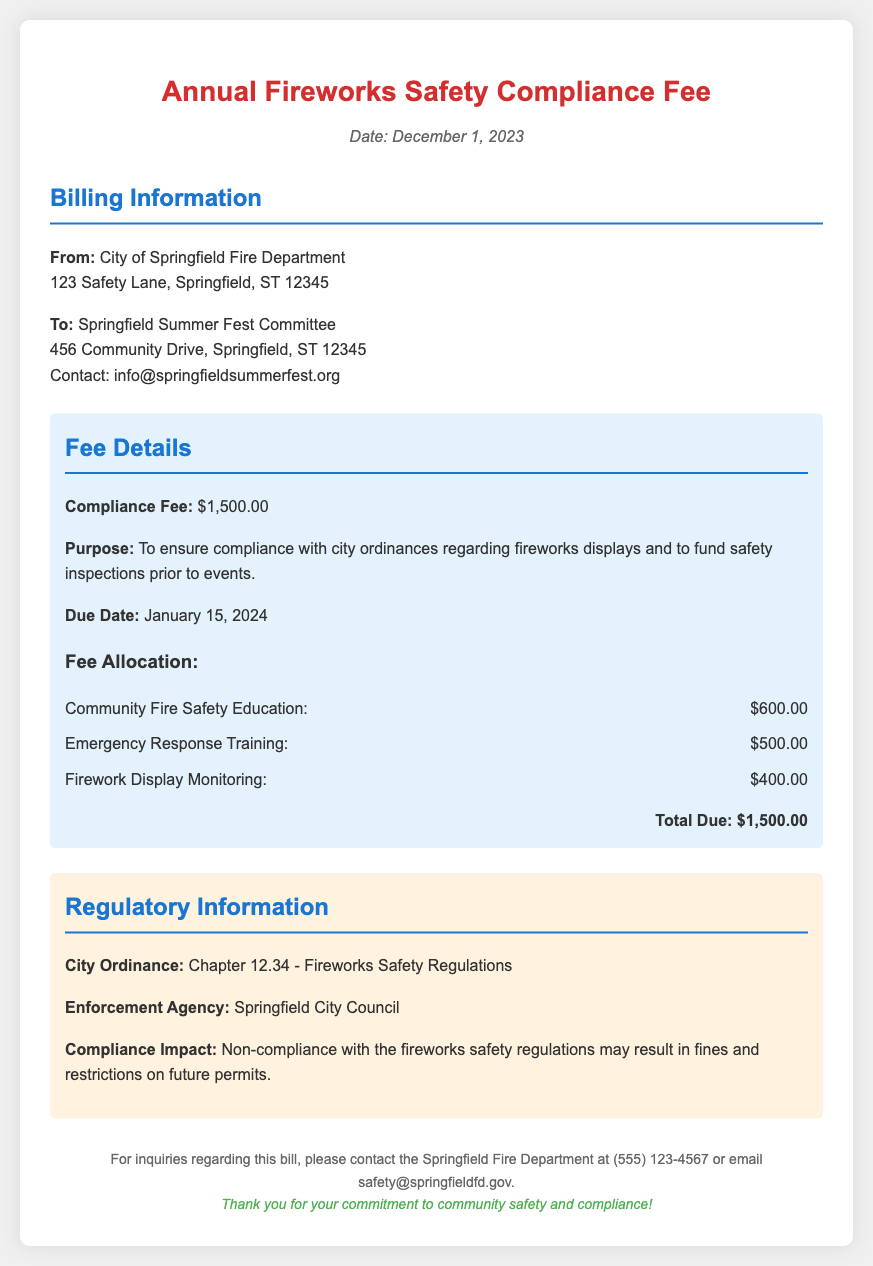What is the compliance fee amount? The compliance fee amount is specified in the bill under Fee Details.
Answer: $1,500.00 When is the due date for payment? The due date is mentioned clearly in the Fee Details section of the bill.
Answer: January 15, 2024 What are the three areas funded by the fee allocation? The bill outlines specific areas allocated from the compliance fee.
Answer: Community Fire Safety Education, Emergency Response Training, Firework Display Monitoring What is the total amount due? The total amount due is summarized as part of the fee details.
Answer: $1,500.00 Which agency enforces the fireworks safety regulations? The enforcing agency is referred to in the Regulatory Information section of the document.
Answer: Springfield City Council What might happen if an organizer does not comply with the regulations? Potential consequences of non-compliance are noted in the document.
Answer: Fines and restrictions on future permits What is the purpose of the compliance fee? The purpose of the fee is mentioned in the Fee Details section of the bill.
Answer: To ensure compliance with city ordinances regarding fireworks displays and to fund safety inspections prior to events How much is allocated for Emergency Response Training? The specific allocation for Emergency Response Training is detailed in the fee allocation section.
Answer: $500.00 What is the contact email for inquiries regarding the bill? The contact email is provided in the footer of the document for inquiries.
Answer: safety@springfieldfd.gov 